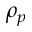<formula> <loc_0><loc_0><loc_500><loc_500>\rho _ { p }</formula> 